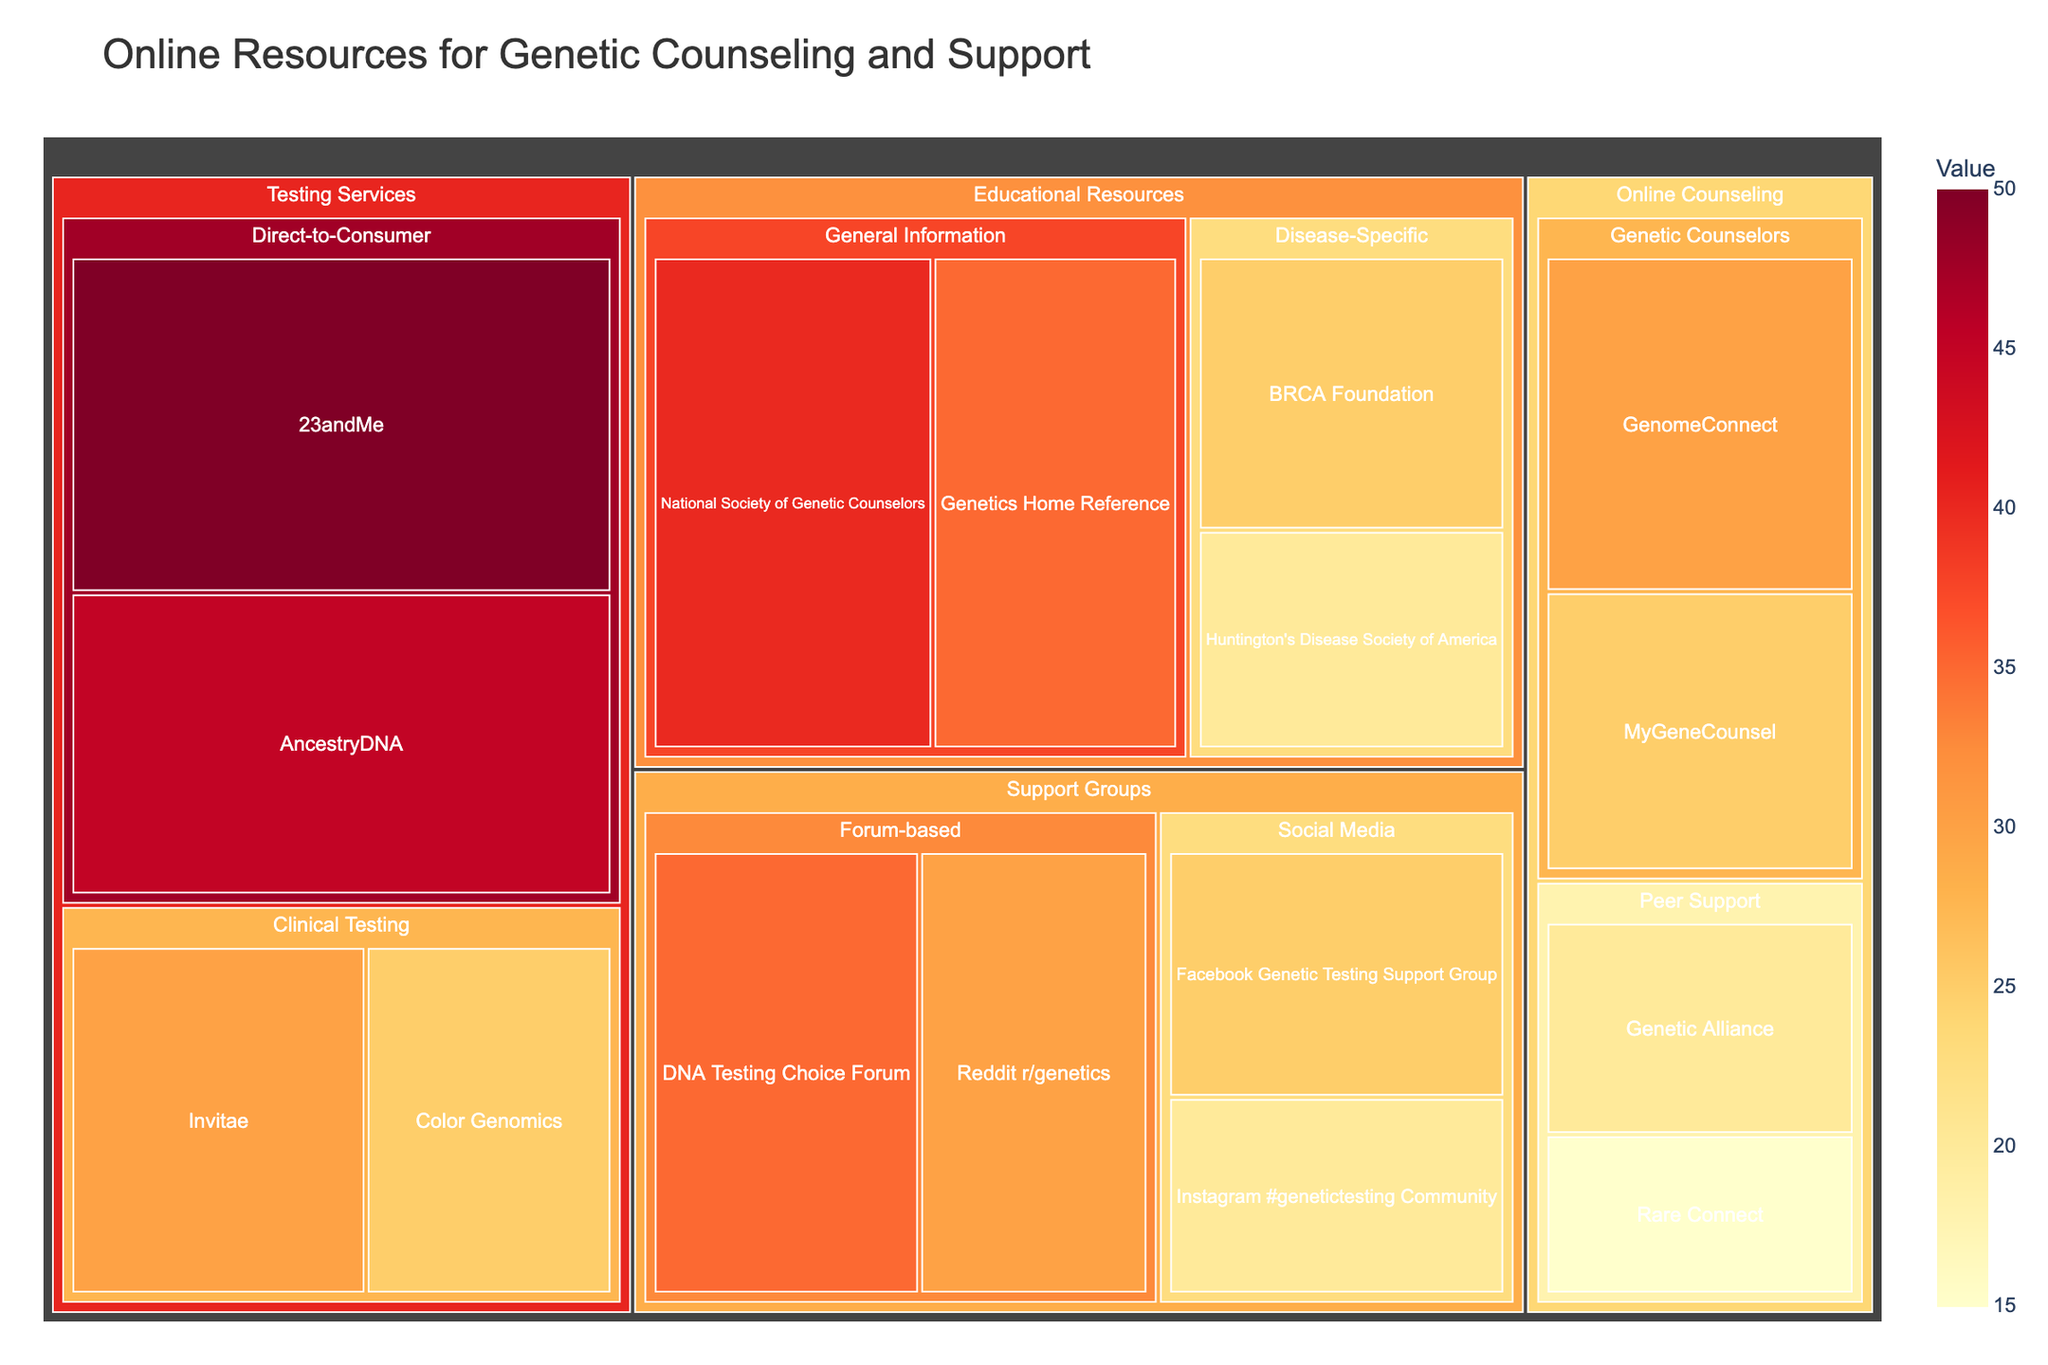What's the title of the figure? The title of the figure is often displayed at the top, providing an overview of the content and topic of the plot. The title here is "Online Resources for Genetic Counseling and Support."
Answer: Online Resources for Genetic Counseling and Support How many categories are shown in the figure? To find the number of categories, look at the top level of the hierarchy in the treemap, which are usually distinctly separated sections. Here, they are "Online Counseling," "Educational Resources," "Testing Services," and "Support Groups."
Answer: 4 Which service under "Educational Resources" has the highest value? Under the "Educational Resources" category, there are several services. By comparing their values, "National Society of Genetic Counselors" has the highest value of 40.
Answer: National Society of Genetic Counselors What is the combined value of the services under "Testing Services"? Add up the values provided for all services within the "Testing Services" category: 23andMe (50), AncestryDNA (45), Invitae (30), and Color Genomics (25).
Answer: 150 Which subcategory of "Online Counseling" has more services and what are they? There are two subcategories under "Online Counseling": "Genetic Counselors" and "Peer Support." Count the services in each. "Genetic Counselors" has two services: GenomeConnect and MyGeneCounsel. "Peer Support" also has two services: Genetic Alliance and Rare Connect.
Answer: Both subcategories have two services each: "GenomeConnect" and "MyGeneCounsel" for Genetic Counselors, "Genetic Alliance" and "Rare Connect" for Peer Support Which category has the largest individual value for a service? Compare the highest values in each category, then determine which one is the largest. "Testing Services" has the largest individual value for the service "23andMe" with 50.
Answer: Testing Services Are there more services under "Direct-to-Consumer" or "Clinical Testing" in the "Testing Services" category, and by how many? Count the number of services under each subcategory: "Direct-to-Consumer" has two services (23andMe and AncestryDNA), and "Clinical Testing" also has two services (Invitae and Color Genomics). The difference is zero.
Answer: Neither; they are equal What category has the lowest total value, and what is that total value? Sum the values for each category, then compare to find the smallest total. 
    - Online Counseling: 30 + 25 + 20 + 15 = 90
    - Educational Resources: 40 + 35 + 25 + 20 = 120
    - Testing Services: 50 + 45 + 30 + 25 = 150
    - Support Groups: 35 + 30 + 25 + 20 = 110.
    
"Online Counseling" has the lowest total value of 90.
Answer: Online Counseling; 90 